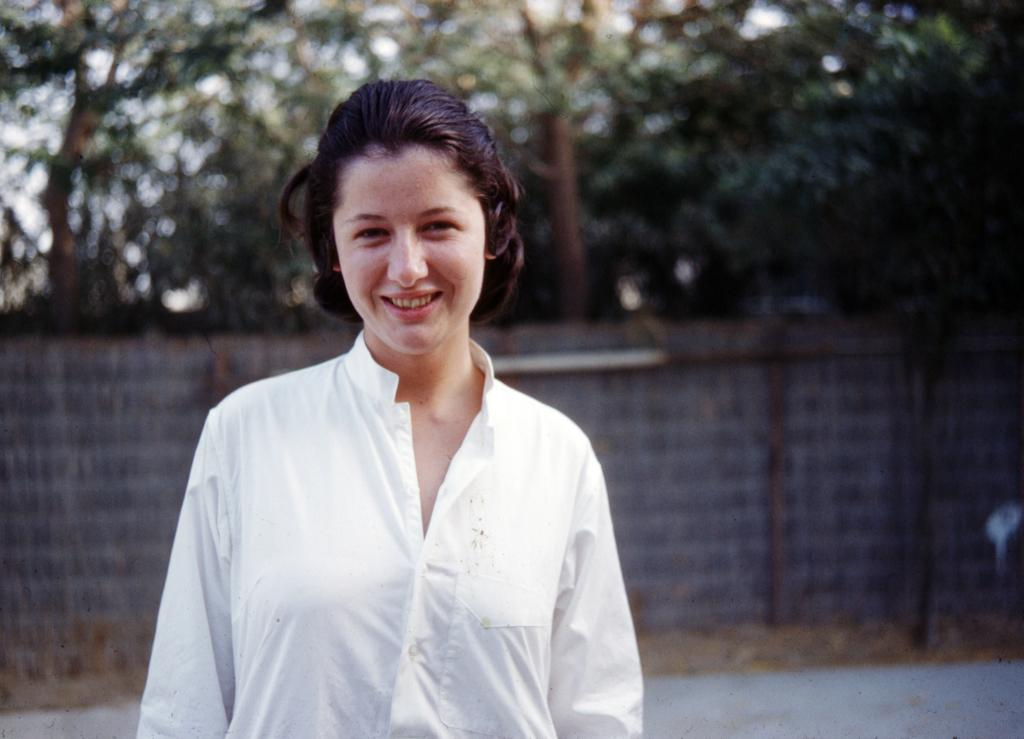Who is the main subject in the image? There is a woman in the image. Where is the woman located in the image? The woman is in the middle of the image. What can be seen in the background of the image? There is a wall in the background of the image, and behind the wall, there are trees. What type of knowledge is the woman sharing with the tent in the image? There is no tent present in the image, and therefore no knowledge can be shared with it. 